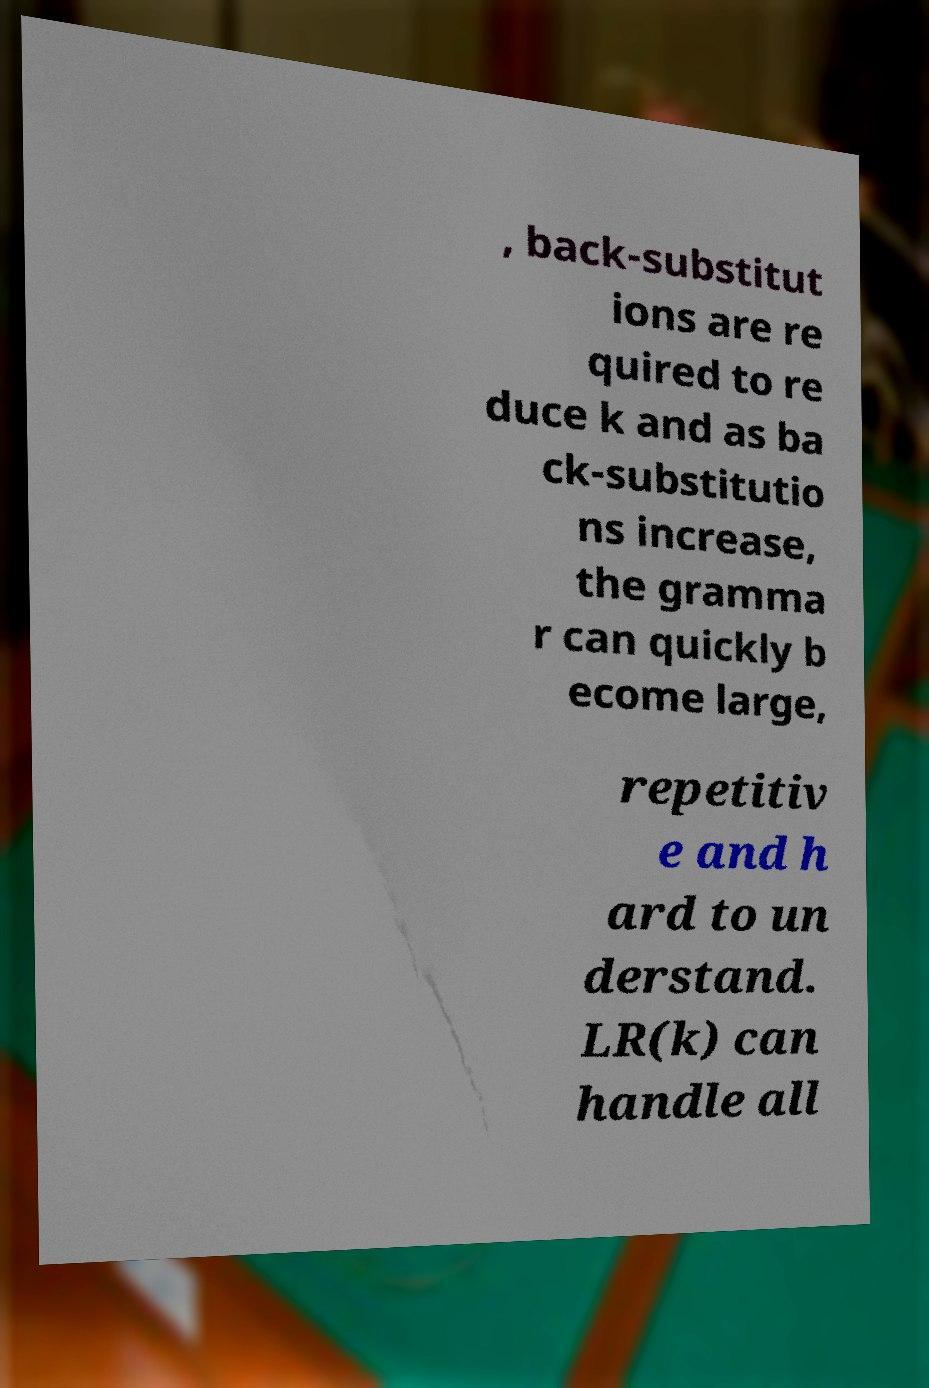What messages or text are displayed in this image? I need them in a readable, typed format. , back-substitut ions are re quired to re duce k and as ba ck-substitutio ns increase, the gramma r can quickly b ecome large, repetitiv e and h ard to un derstand. LR(k) can handle all 